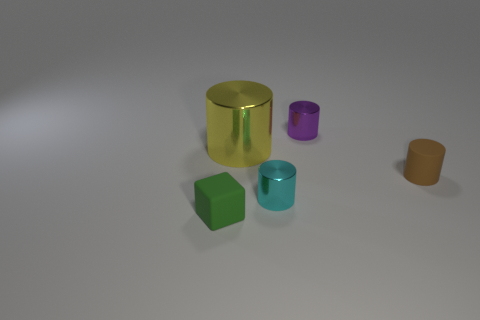Add 4 tiny cyan metal things. How many objects exist? 9 Subtract all blocks. How many objects are left? 4 Add 4 brown cylinders. How many brown cylinders are left? 5 Add 1 large gray things. How many large gray things exist? 1 Subtract 1 green cubes. How many objects are left? 4 Subtract all tiny green matte things. Subtract all small metallic things. How many objects are left? 2 